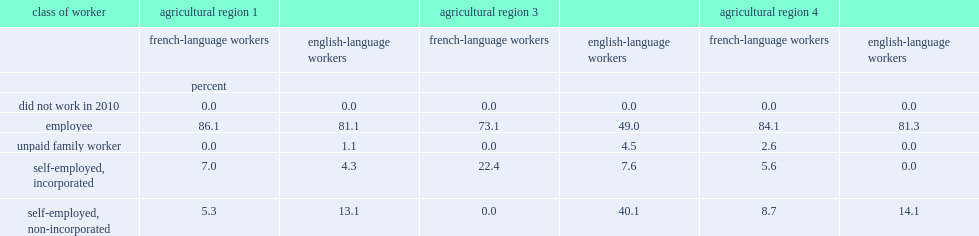What class of worker is the majority of french-language agricultural workers in 2011, with proportions ranging from 73.1% (new brunswick agricultural region 3) to 86.1% (agricultural region 1)? Employee. What class of worker has a higher proportion of french-language workers compared with english-language workers? Employee. Could you parse the entire table? {'header': ['class of worker', 'agricultural region 1', '', 'agricultural region 3', '', 'agricultural region 4', ''], 'rows': [['', 'french-language workers', 'english-language workers', 'french-language workers', 'english-language workers', 'french-language workers', 'english-language workers'], ['', 'percent', '', '', '', '', ''], ['did not work in 2010', '0.0', '0.0', '0.0', '0.0', '0.0', '0.0'], ['employee', '86.1', '81.1', '73.1', '49.0', '84.1', '81.3'], ['unpaid family worker', '0.0', '1.1', '0.0', '4.5', '2.6', '0.0'], ['self-employed, incorporated', '7.0', '4.3', '22.4', '7.6', '5.6', '0.0'], ['self-employed, non-incorporated', '5.3', '13.1', '0.0', '40.1', '8.7', '14.1']]} 